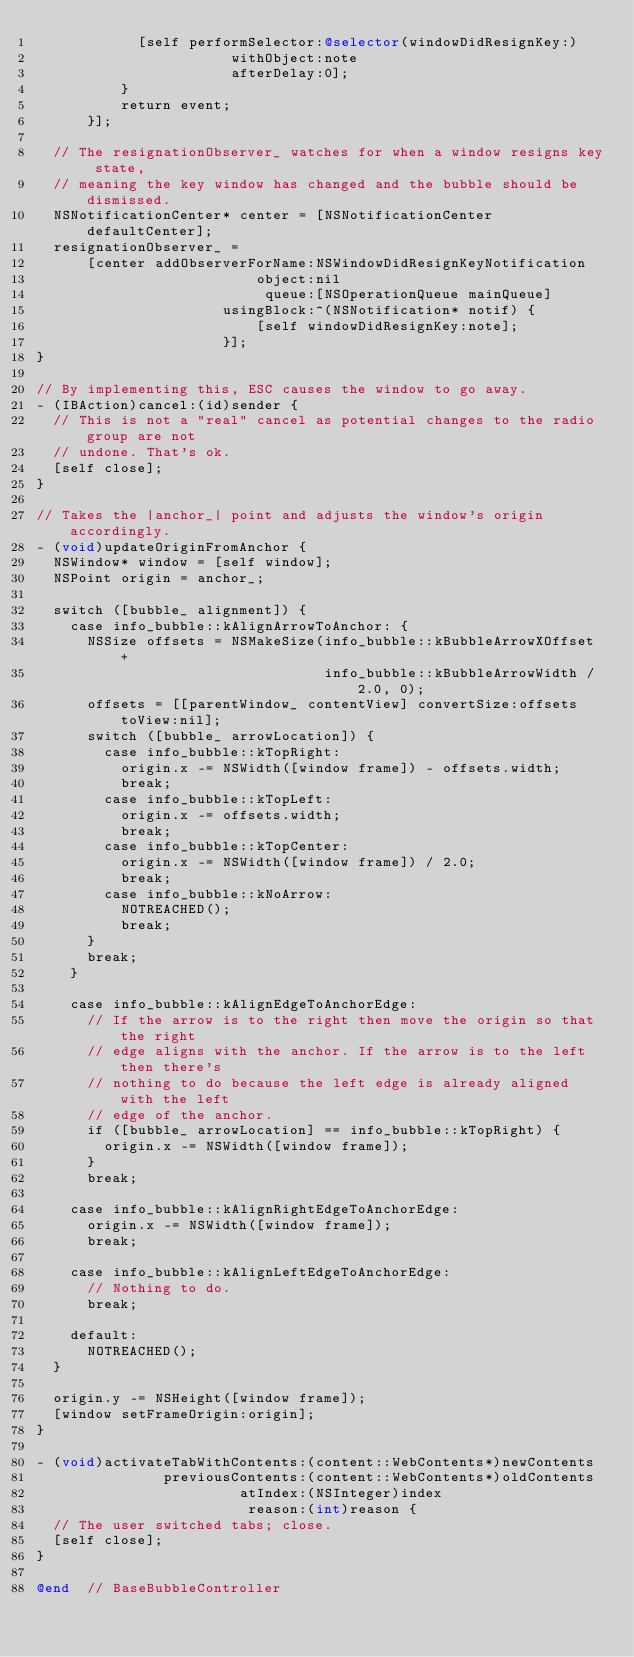Convert code to text. <code><loc_0><loc_0><loc_500><loc_500><_ObjectiveC_>            [self performSelector:@selector(windowDidResignKey:)
                       withObject:note
                       afterDelay:0];
          }
          return event;
      }];

  // The resignationObserver_ watches for when a window resigns key state,
  // meaning the key window has changed and the bubble should be dismissed.
  NSNotificationCenter* center = [NSNotificationCenter defaultCenter];
  resignationObserver_ =
      [center addObserverForName:NSWindowDidResignKeyNotification
                          object:nil
                           queue:[NSOperationQueue mainQueue]
                      usingBlock:^(NSNotification* notif) {
                          [self windowDidResignKey:note];
                      }];
}

// By implementing this, ESC causes the window to go away.
- (IBAction)cancel:(id)sender {
  // This is not a "real" cancel as potential changes to the radio group are not
  // undone. That's ok.
  [self close];
}

// Takes the |anchor_| point and adjusts the window's origin accordingly.
- (void)updateOriginFromAnchor {
  NSWindow* window = [self window];
  NSPoint origin = anchor_;

  switch ([bubble_ alignment]) {
    case info_bubble::kAlignArrowToAnchor: {
      NSSize offsets = NSMakeSize(info_bubble::kBubbleArrowXOffset +
                                  info_bubble::kBubbleArrowWidth / 2.0, 0);
      offsets = [[parentWindow_ contentView] convertSize:offsets toView:nil];
      switch ([bubble_ arrowLocation]) {
        case info_bubble::kTopRight:
          origin.x -= NSWidth([window frame]) - offsets.width;
          break;
        case info_bubble::kTopLeft:
          origin.x -= offsets.width;
          break;
        case info_bubble::kTopCenter:
          origin.x -= NSWidth([window frame]) / 2.0;
          break;
        case info_bubble::kNoArrow:
          NOTREACHED();
          break;
      }
      break;
    }

    case info_bubble::kAlignEdgeToAnchorEdge:
      // If the arrow is to the right then move the origin so that the right
      // edge aligns with the anchor. If the arrow is to the left then there's
      // nothing to do because the left edge is already aligned with the left
      // edge of the anchor.
      if ([bubble_ arrowLocation] == info_bubble::kTopRight) {
        origin.x -= NSWidth([window frame]);
      }
      break;

    case info_bubble::kAlignRightEdgeToAnchorEdge:
      origin.x -= NSWidth([window frame]);
      break;

    case info_bubble::kAlignLeftEdgeToAnchorEdge:
      // Nothing to do.
      break;

    default:
      NOTREACHED();
  }

  origin.y -= NSHeight([window frame]);
  [window setFrameOrigin:origin];
}

- (void)activateTabWithContents:(content::WebContents*)newContents
               previousContents:(content::WebContents*)oldContents
                        atIndex:(NSInteger)index
                         reason:(int)reason {
  // The user switched tabs; close.
  [self close];
}

@end  // BaseBubbleController
</code> 